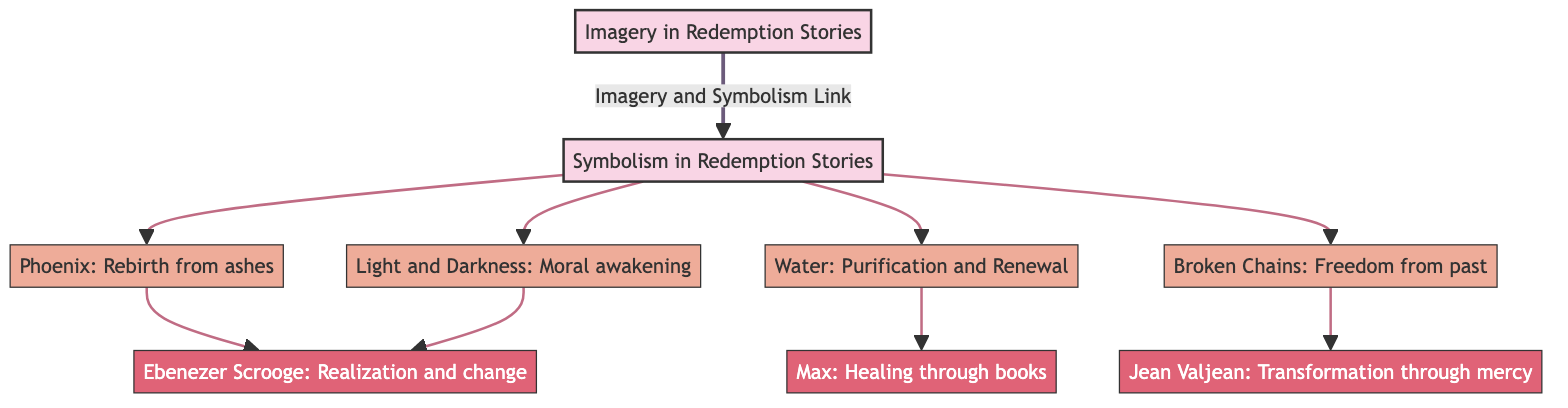What is the main focus of the diagram? The diagram primarily explores "Imagery in Redemption Stories," indicated by the starting node labeled as such. It sets the foundational theme of the visual representation.
Answer: Imagery in Redemption Stories How many symbolism nodes are there in the diagram? The diagram lists four distinct symbolism nodes: Phoenix, Water, Broken Chains, and Light and Darkness, which can be counted directly from the branches stemming from the Symbolism in Redemption Stories node.
Answer: Four Which character is associated with the symbolism of the Phoenix? The Phoenix symbolizes rejuvenation and rebirth, linked to Ebenezer Scrooge, whose transformation culminates in realization and change, clarified by the diagram's directional flow.
Answer: Ebenezer Scrooge What does Water symbolize in redemption narratives? Water is represented as a symbol of purification and renewal, which is noted adjacent to the corresponding symbolism node in the diagram.
Answer: Purification and Renewal Which character is linked to Broken Chains and what does it represent? Jean Valjean is the character associated with Broken Chains, which signifies freedom from the past, demonstrated by the direct connection from the Broken Chains symbol to Jean Valjean in the diagram.
Answer: Jean Valjean: Freedom from past How do the symbols Light and Darkness contribute to overarching themes? The symbolism of Light and Darkness indicates moral awakening, serving as a crucial theme connected to multiple characters, including the repeat linkage to Ebenezer Scrooge, who evolves through this moral journey.
Answer: Moral awakening How do Max's experiences relate to Water symbolism? Max's character embodies healing through books, reflecting Water's role in purification and renewal, as denoted in the diagram by their mutual connection through the Water node.
Answer: Healing through books What is the significance of the arrows in the diagram? The arrows in the diagram illustrate the connections between the symbols and the respective characters, emphasizing the transformation and interplay of imagery and symbolism throughout redemption narratives.
Answer: Connections between symbols and characters What does the symbol of Light and Darkness share in significance with the Phoenix symbolism? Both Light and Darkness as well as Phoenix revolve around themes of transformation; while the Phoenix represents a physical rebirth, Light and Darkness symbolize moral awakening, indicating a comprehensive interrelationship in thematic development.
Answer: Transformation and moral awakening 